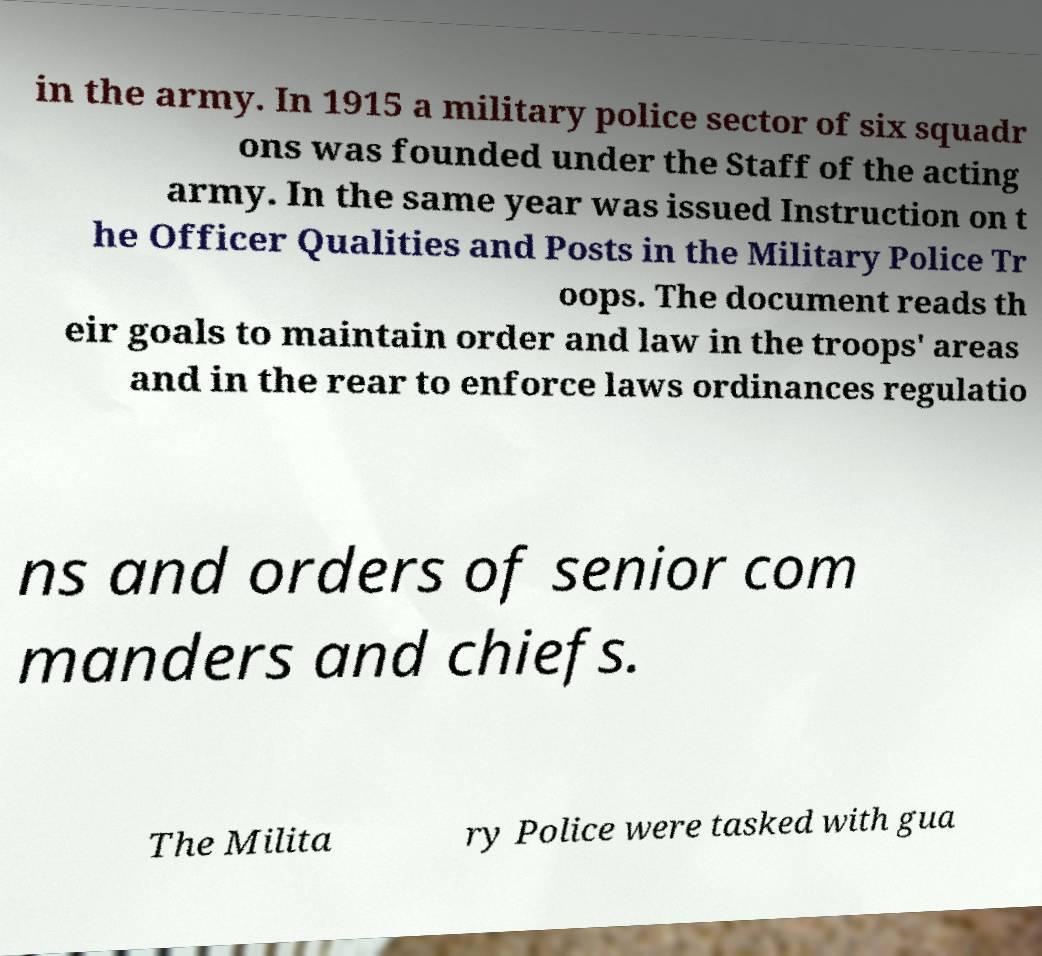Please read and relay the text visible in this image. What does it say? in the army. In 1915 a military police sector of six squadr ons was founded under the Staff of the acting army. In the same year was issued Instruction on t he Officer Qualities and Posts in the Military Police Tr oops. The document reads th eir goals to maintain order and law in the troops' areas and in the rear to enforce laws ordinances regulatio ns and orders of senior com manders and chiefs. The Milita ry Police were tasked with gua 